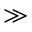<formula> <loc_0><loc_0><loc_500><loc_500>\gg</formula> 